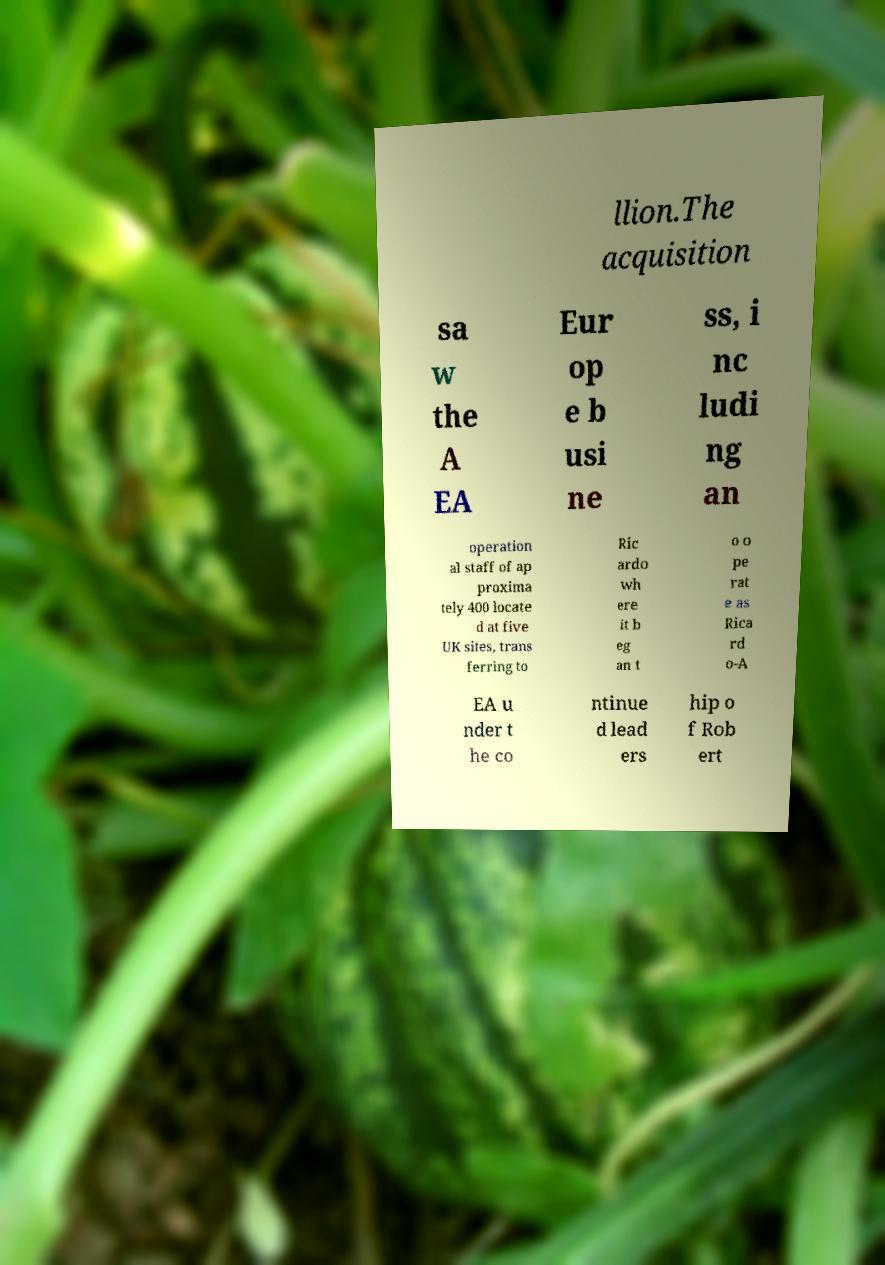Please identify and transcribe the text found in this image. llion.The acquisition sa w the A EA Eur op e b usi ne ss, i nc ludi ng an operation al staff of ap proxima tely 400 locate d at five UK sites, trans ferring to Ric ardo wh ere it b eg an t o o pe rat e as Rica rd o-A EA u nder t he co ntinue d lead ers hip o f Rob ert 